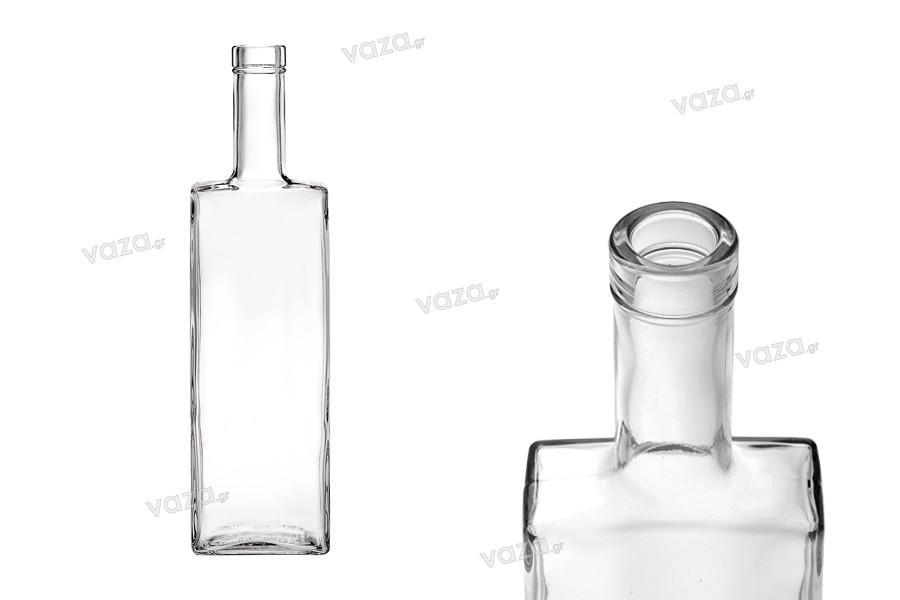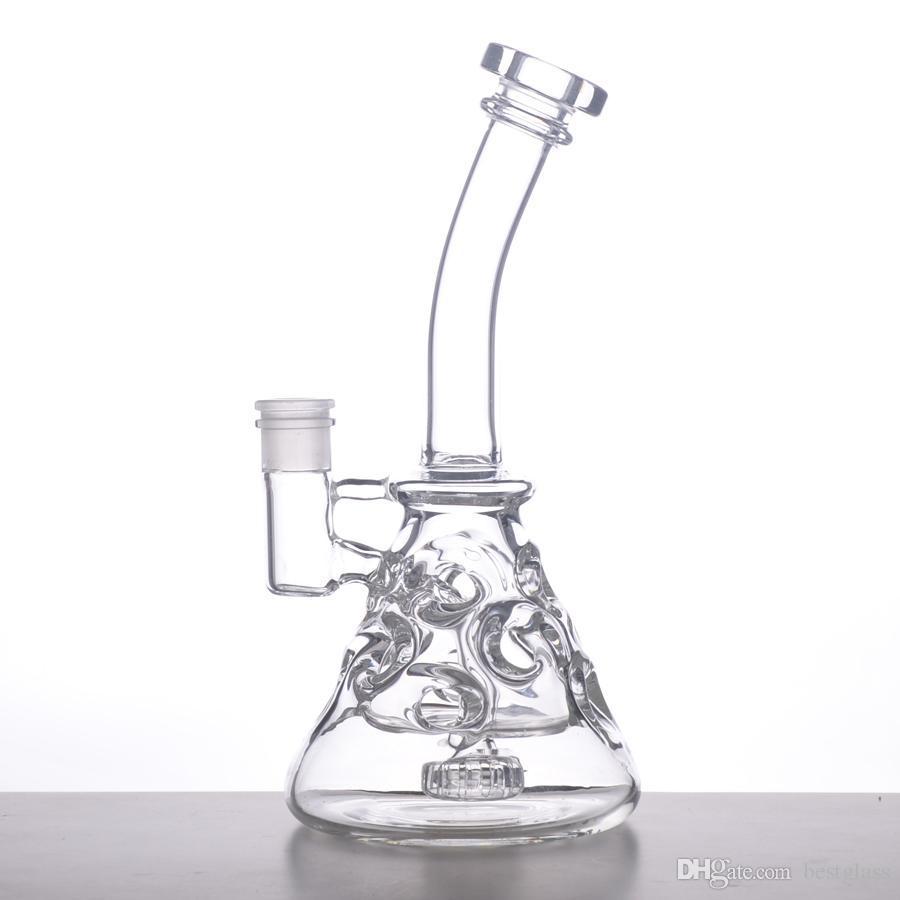The first image is the image on the left, the second image is the image on the right. For the images shown, is this caption "There is at least one beaker looking bong in the image." true? Answer yes or no. Yes. The first image is the image on the left, the second image is the image on the right. Considering the images on both sides, is "One of the images has only a single flask, and it has blue liquid in it." valid? Answer yes or no. No. 